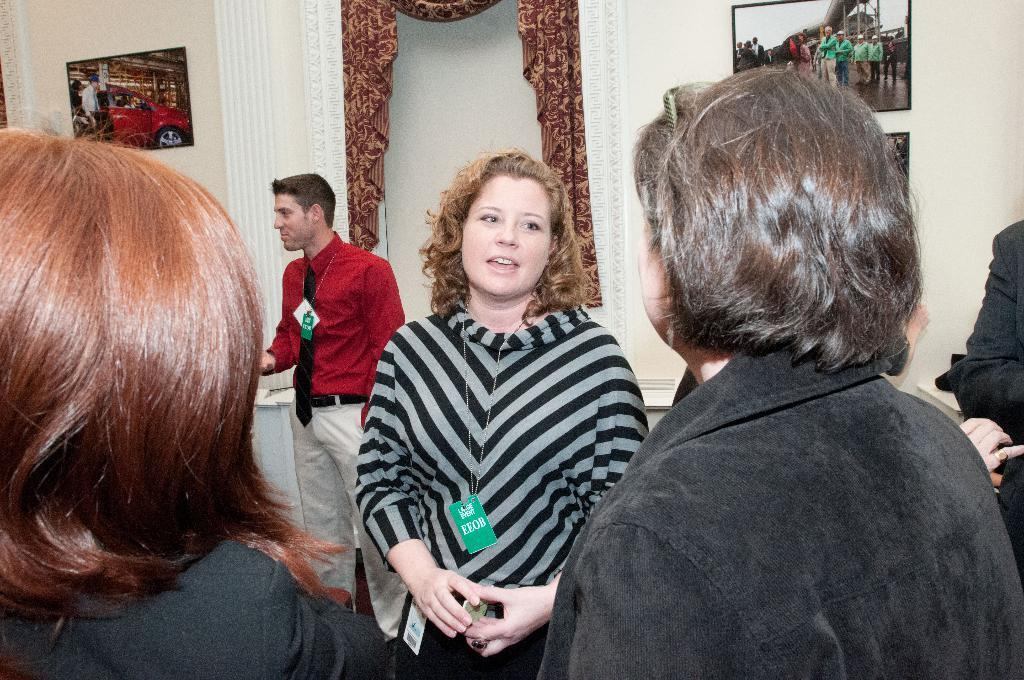Who or what can be seen in the image? There are people in the image. What are the people wearing that is visible in the image? The people are wearing tags. What can be seen on the wall in the image? There are frames on the wall in the image. What type of key is being used to open the meal in the image? There is no key or meal present in the image. How many mittens can be seen on the people in the image? There are no mittens visible in the image; the people are wearing tags. 